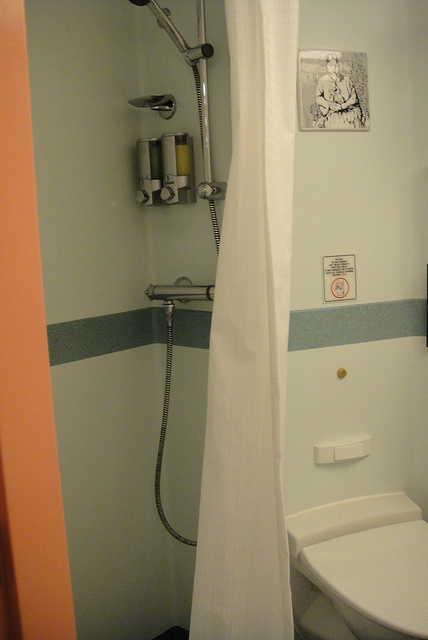Describe the objects in this image and their specific colors. I can see a toilet in tan, darkgreen, and gray tones in this image. 